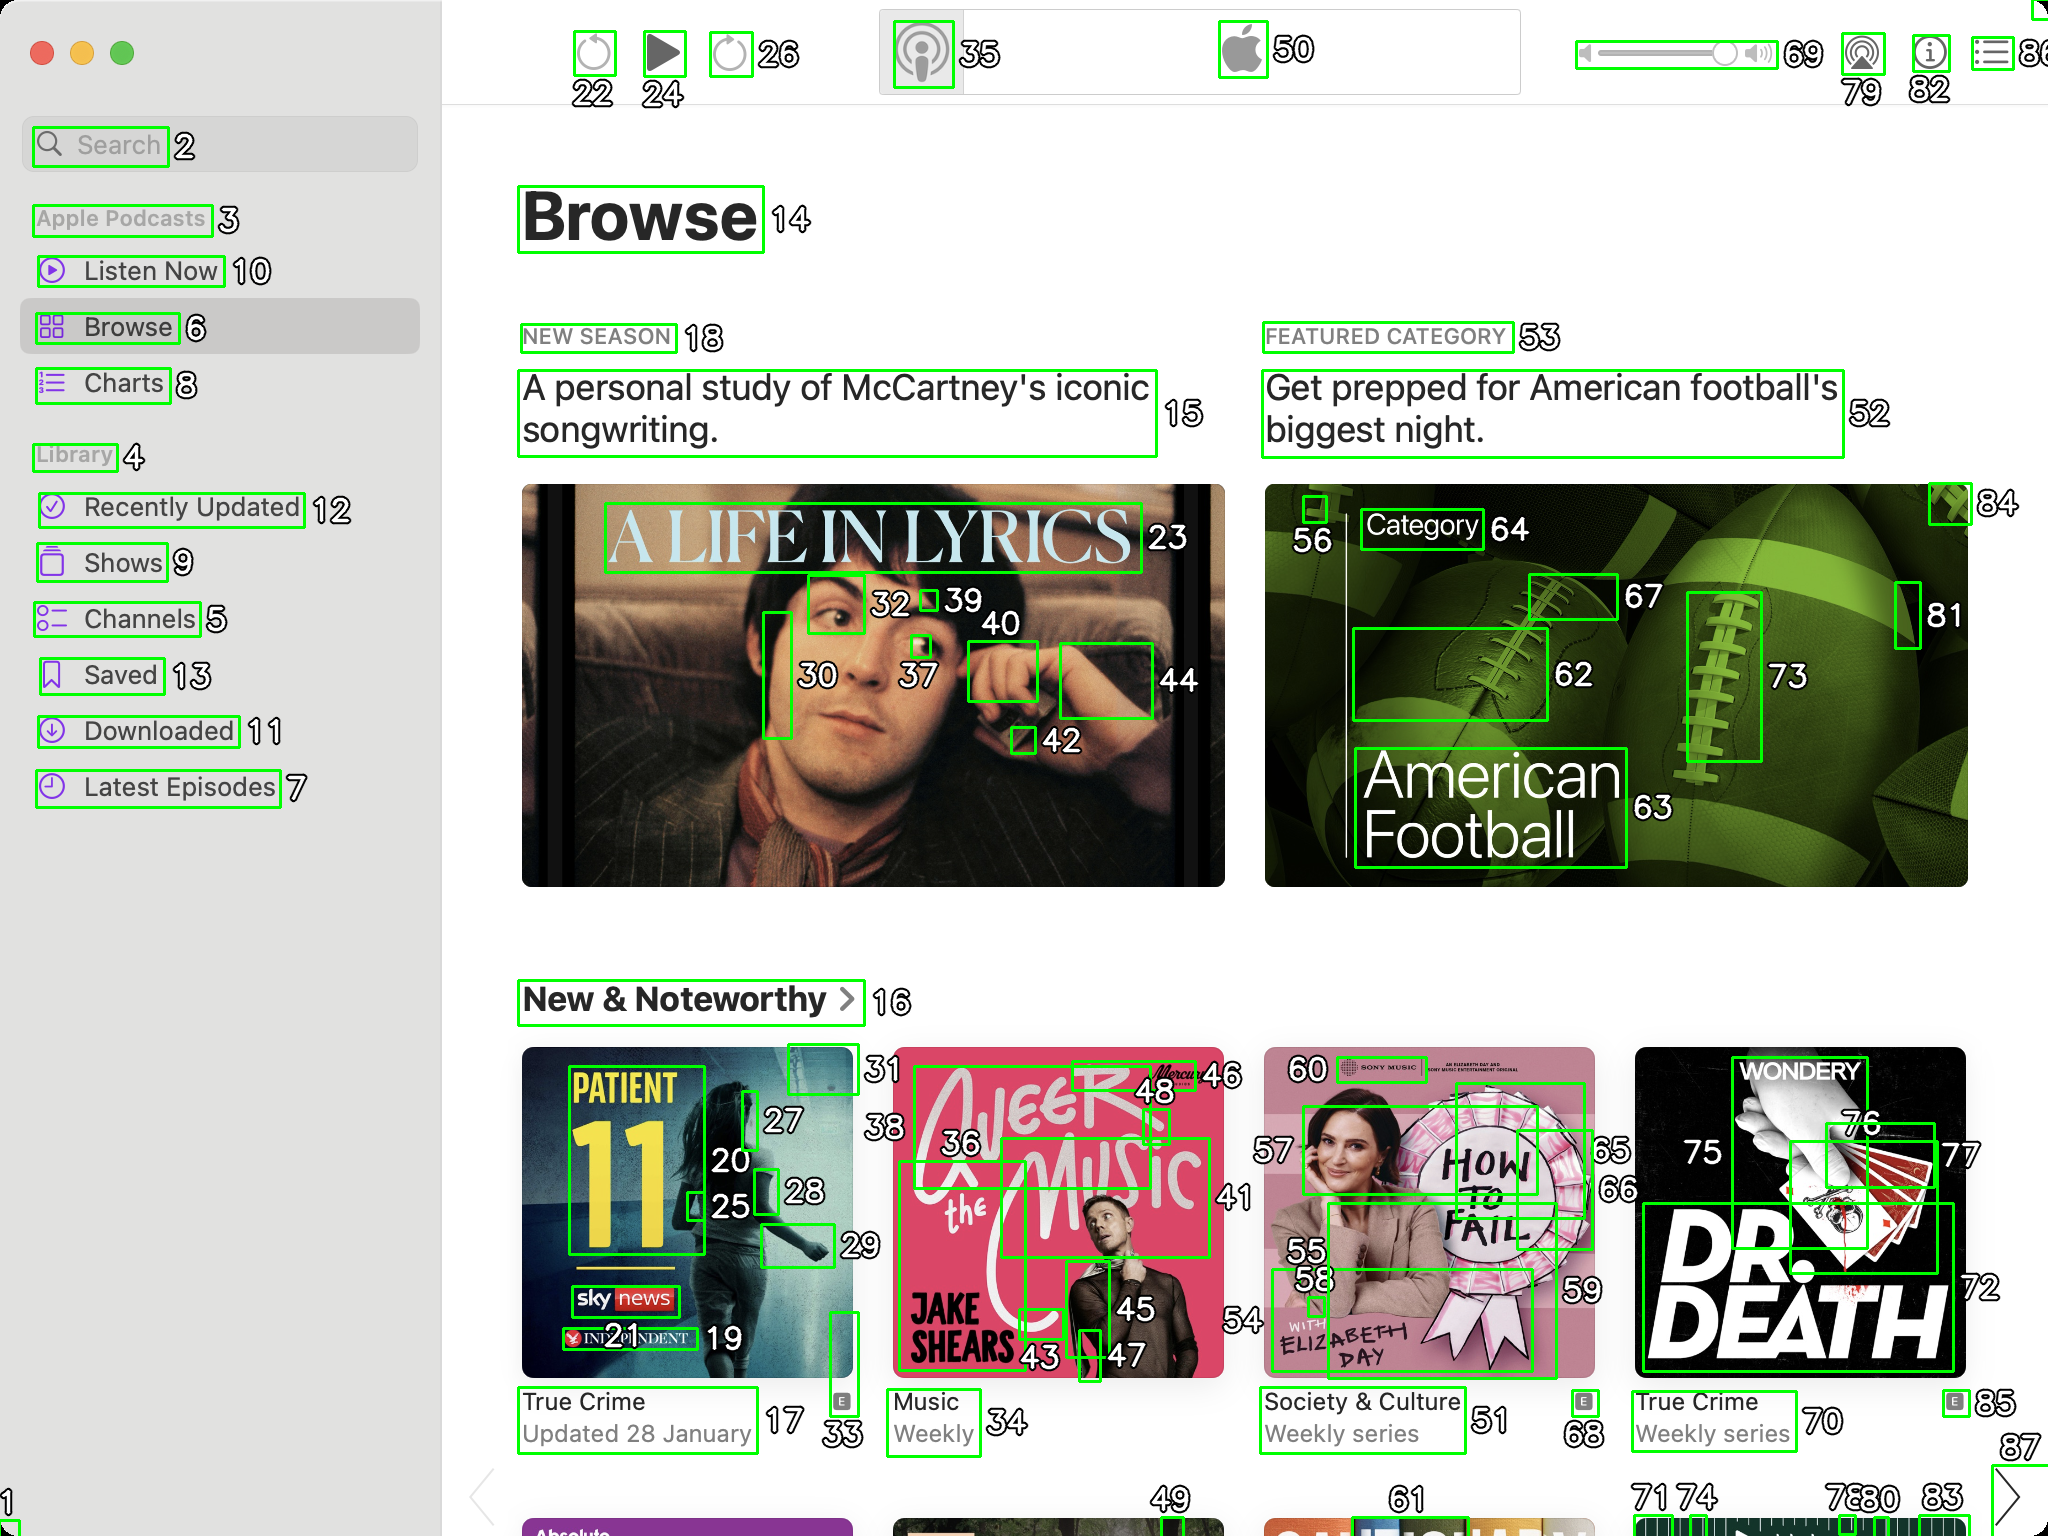You are an AI designed for image processing and segmentation analysis, particularly skilled in merging segmented regions of an image to improve accuracy and readability.

**Task Description:**
Your task is to address a user's concern with a UI screenshot of the Apple Podcasts application on MacOS. The screenshot contains multiple green boxes, each representing a UI element, with a unique white number outlined in black ranging from 1 to 88. Due to segmentation issues, some boxes that belong to the same UI element are divided unnaturally.

**Objective:**
Merge these segmented areas that correspond to a single UI element to create a coherent representation. The final output should be in JSON format, where each key-value pair represents the merged areas.

**Example JSON Output:**
If boxes with numbers 1, 2, and 3 should belong to the same UI element, the JSON output should be:

```json
{
    "UI Element 1": [1, 2, 3]
}
```

**Instructions:**

- **Identify Segmented Regions:** Analyze the screenshot to identify which green boxes belong to the same UI element.
- **Merge Regions:** Group the numbers of these boxes together to represent a single UI element.
- **Output Format:** Produce the output in JSON format, with each key representing a UI element and each value being a list of the numbers of the merged boxes.

**Primary Objective:**
Ensure the accuracy of the merged regions based on the user's supplied image information, maintaining the integrity and structure of the UI elements in the Apple Podcasts application on MacOS. Based on the provided screenshot, I have identified and merged the segmented regions that correspond to the same UI elements. Here is the JSON output representing the merged areas:

```json
{
    "Search Box": [1, 2],
    "Apple Podcasts Button": [3],
    "Listen Now Button": [10],
    "Browse Button": [6],
    "Charts Button": [8],
    "Library Section": [4, 7, 9, 5, 13, 11],
    "Recently Updated Button": [12],
    "Browse Header": [14],
    "New Season Label": [18],
    "McCartney Iconic Songwriting": [15, 23, 39, 30, 37, 40, 42, 44],
    "Featured Category Label": [53],
    "American Football Preparation": [52, 64, 62, 63, 73, 81, 84],
    "New & Noteworthy Label": [16],
    "Patient 11 Podcast": [17, 19, 20, 25, 27, 28, 33],
    "Jake Shears Podcast": [35, 36, 43, 45, 46, 48],
    "Elizabeth Day Podcast": [50, 55, 57, 58, 59, 60],
    "True Crime Weekly Series": [70, 75, 76, 77, 72],
    "Logo Buttons": [22, 24, 26, 50, 69, 79, 82]
}
```

This JSON output represents the merged segments of UI elements based on the numbers provided in the screenshot. Each key represents a UI element, and the values are lists of the numbers of the merged boxes that correspond to that specific element. 